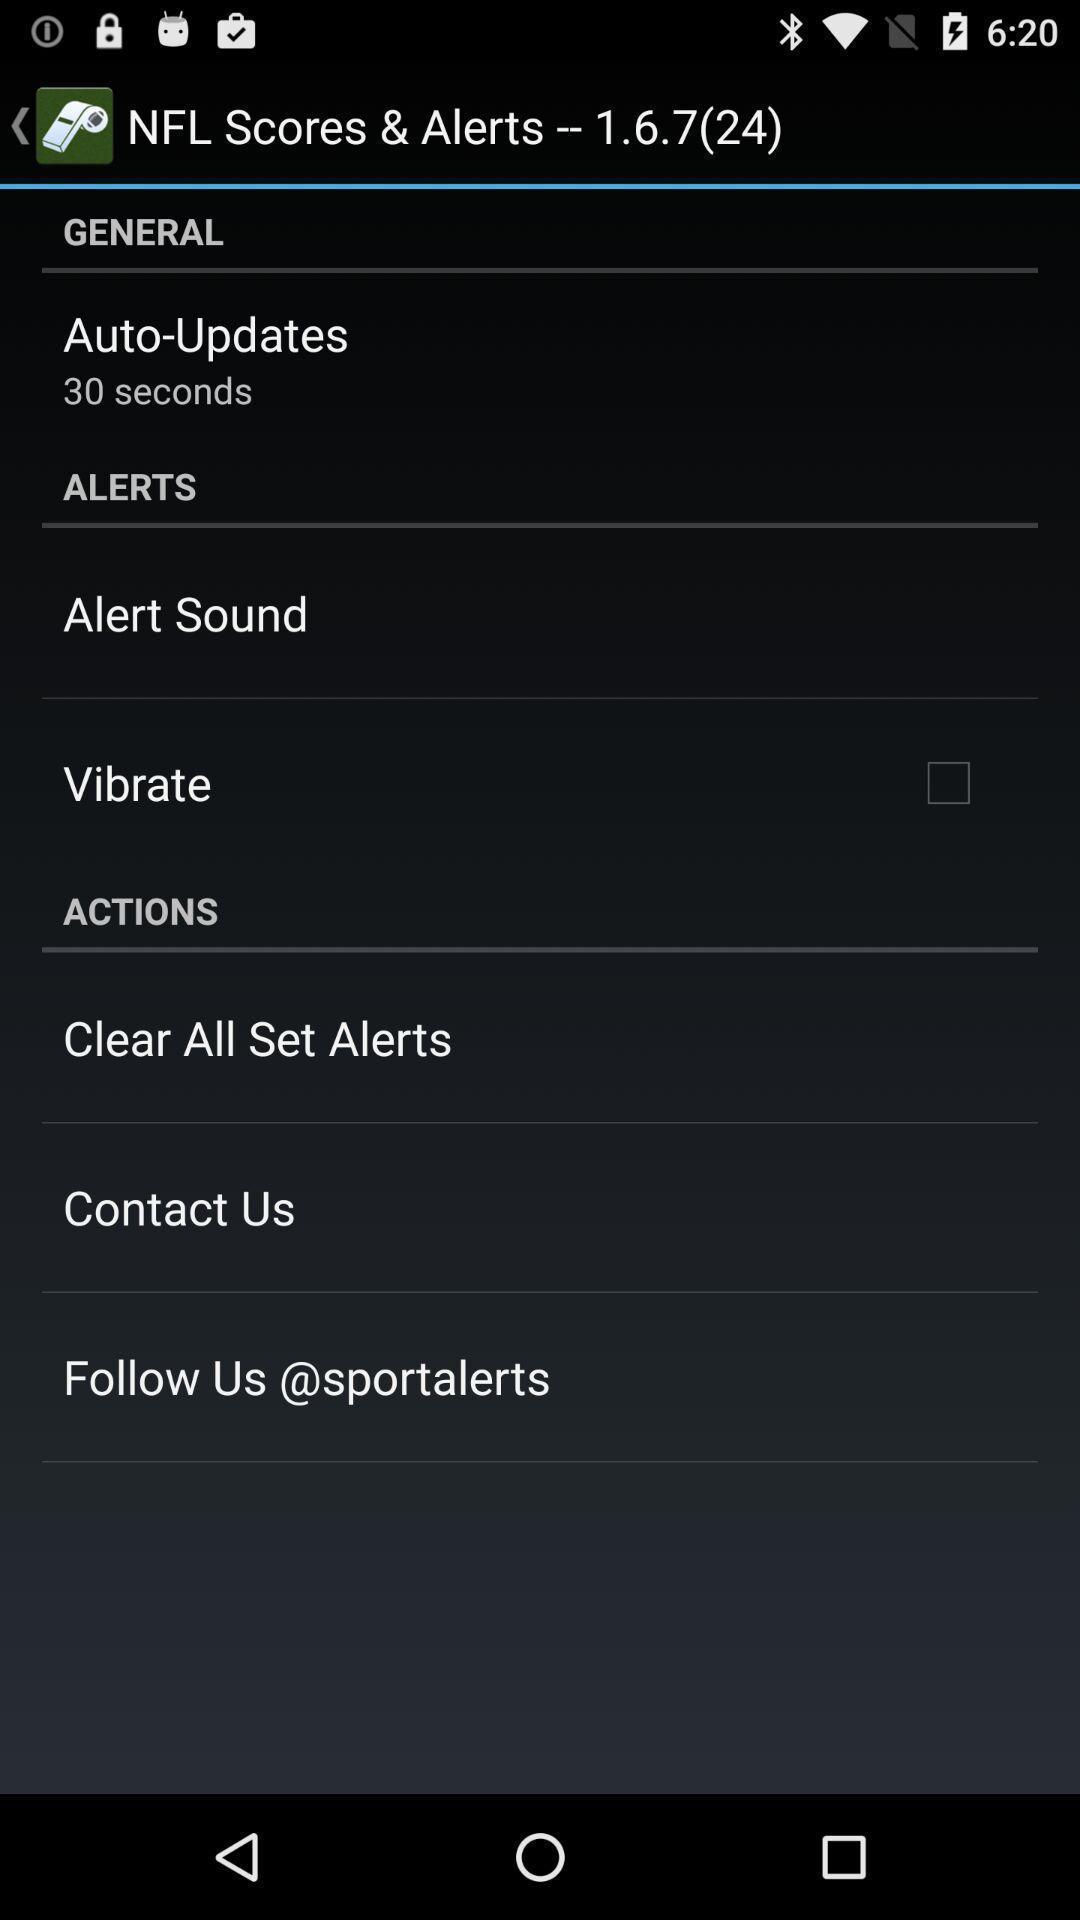Provide a textual representation of this image. Screen shows settings page in sports application. 